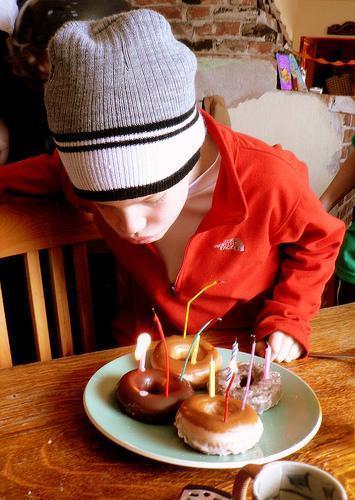How many donuts are on the plate?
Give a very brief answer. 4. How many candles are there?
Give a very brief answer. 11. 